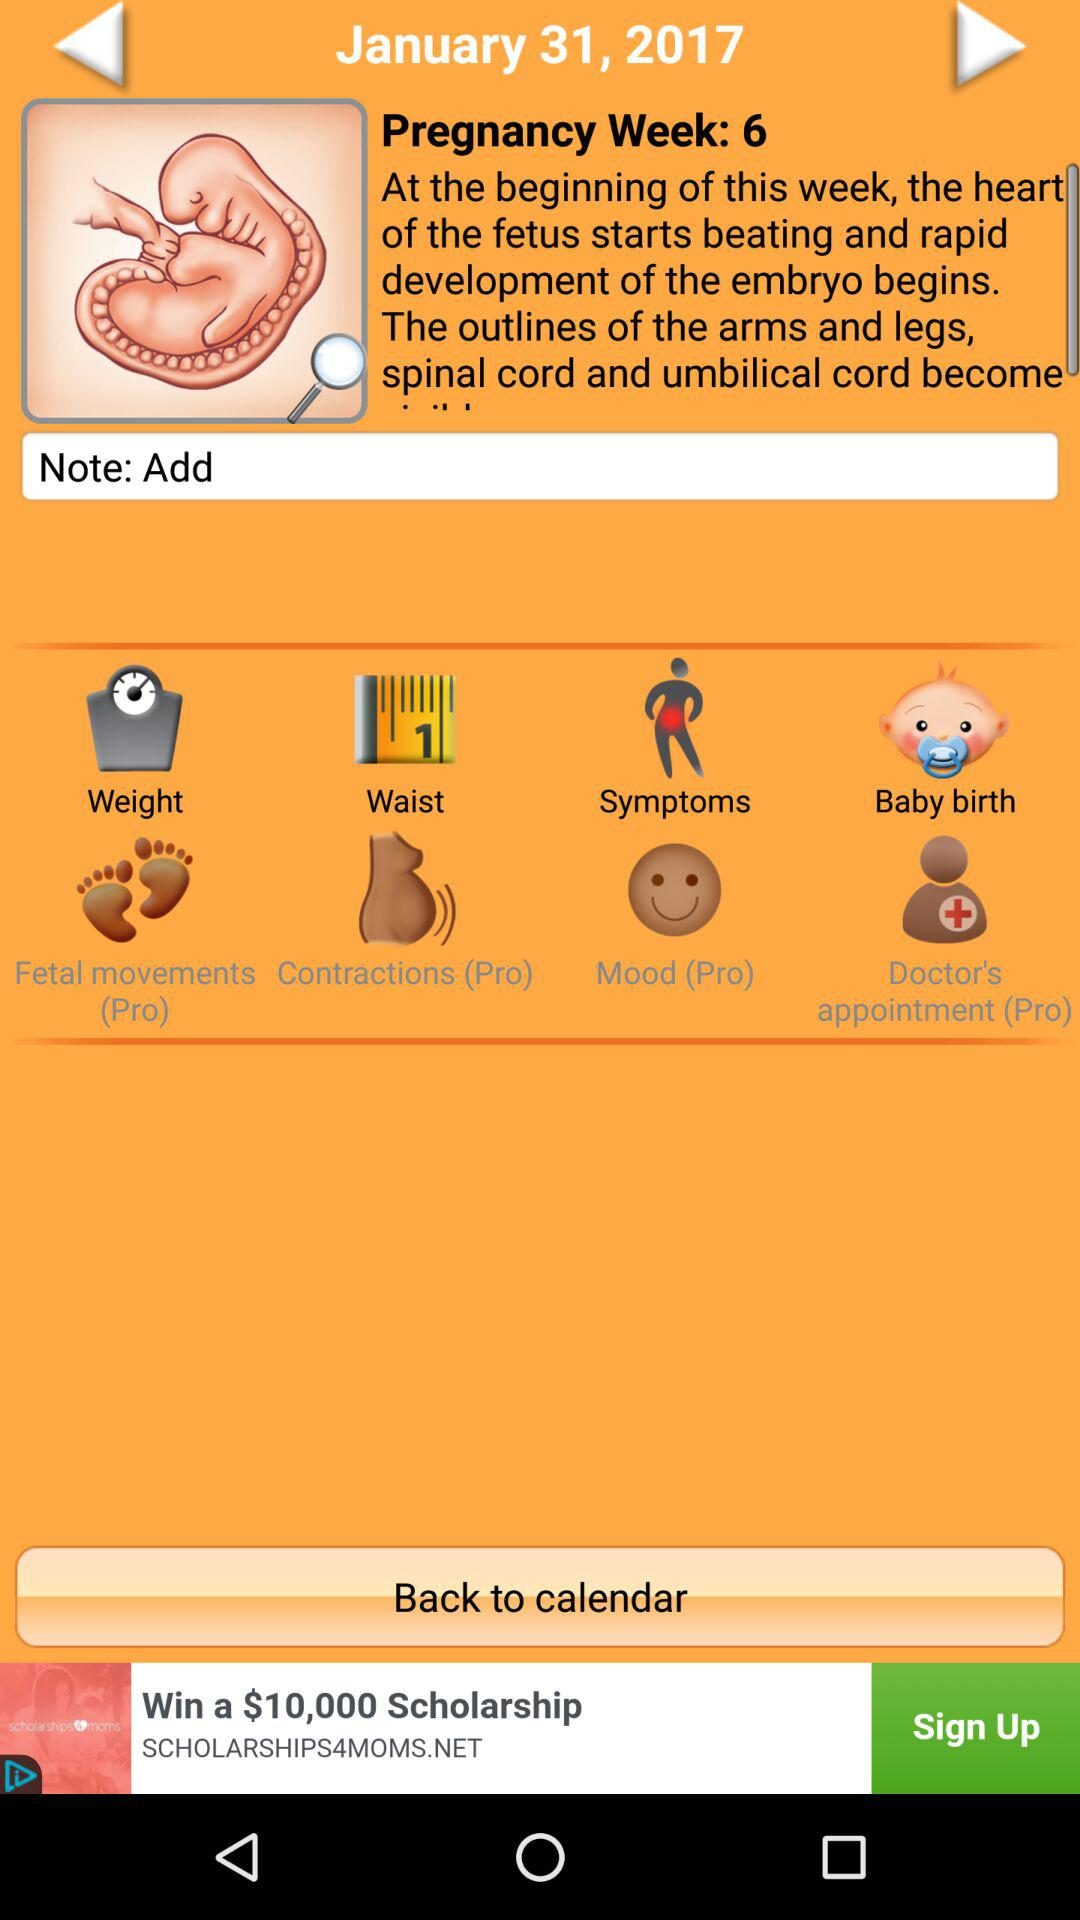What is the pregnancy week number? The pregnancy week number is 6. 